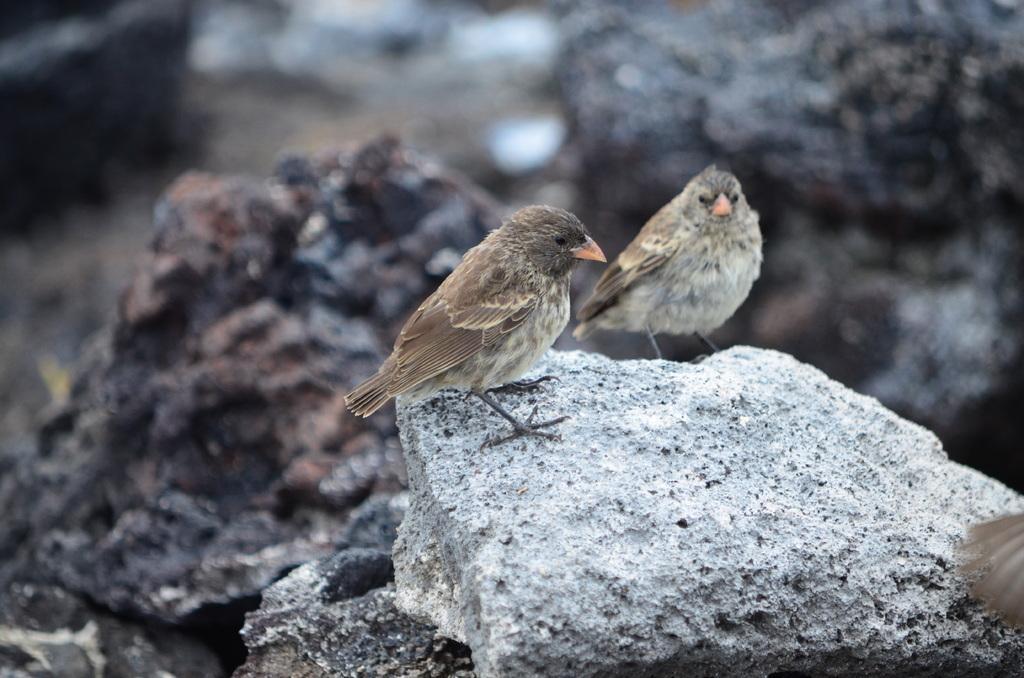Can you describe this image briefly? In this image there are two birds standing on the rocks, behind the birds there are rocks. 